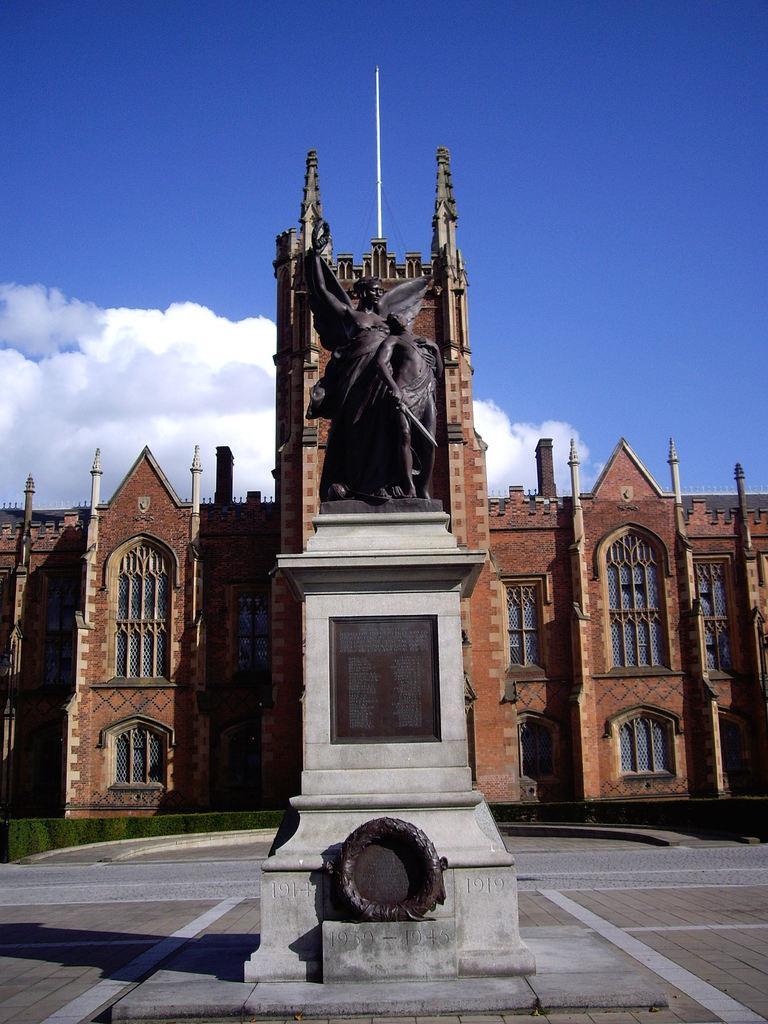Could you give a brief overview of what you see in this image? In this image there is are sculptures of persons on the block, there is a building and some clouds in the sky. 